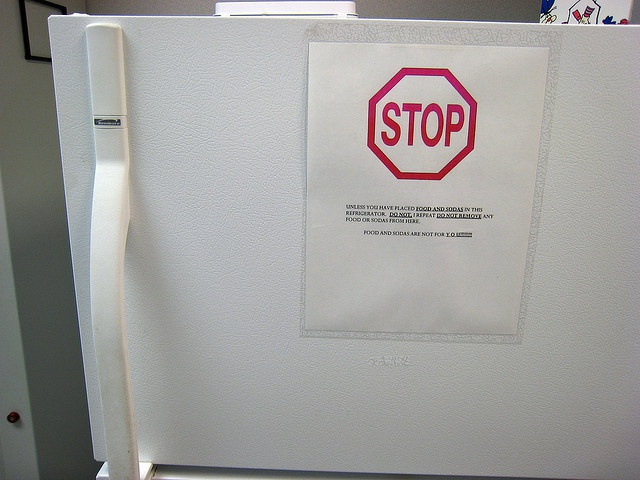Describe the objects in this image and their specific colors. I can see refrigerator in darkgray, gray, and lightgray tones and stop sign in gray, brown, lightgray, and darkgray tones in this image. 